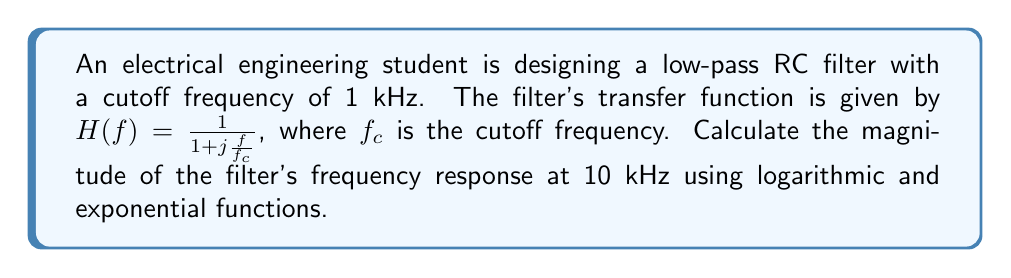Provide a solution to this math problem. 1) The magnitude of the transfer function is given by:
   $$|H(f)| = \frac{1}{\sqrt{1 + (\frac{f}{f_c})^2}}$$

2) We're given:
   $f_c = 1$ kHz
   $f = 10$ kHz

3) Substituting these values:
   $$|H(10\text{ kHz})| = \frac{1}{\sqrt{1 + (\frac{10\text{ kHz}}{1\text{ kHz}})^2}} = \frac{1}{\sqrt{1 + 10^2}}$$

4) Simplify under the square root:
   $$|H(10\text{ kHz})| = \frac{1}{\sqrt{101}}$$

5) To use logarithmic functions, we can express this in decibels:
   $$|H(10\text{ kHz})|_{\text{dB}} = 20 \log_{10}(\frac{1}{\sqrt{101}})$$

6) Using the logarithm property $\log(1/x) = -\log(x)$:
   $$|H(10\text{ kHz})|_{\text{dB}} = -20 \log_{10}(\sqrt{101})$$

7) Using the logarithm property $\log(\sqrt{x}) = \frac{1}{2}\log(x)$:
   $$|H(10\text{ kHz})|_{\text{dB}} = -10 \log_{10}(101)$$

8) Calculating:
   $$|H(10\text{ kHz})|_{\text{dB}} \approx -20.04\text{ dB}$$

9) To convert back to a magnitude, we use the exponential function:
   $$|H(10\text{ kHz})| = 10^{\frac{-20.04}{20}} \approx 0.0995$$
Answer: $0.0995$ or $-20.04\text{ dB}$ 